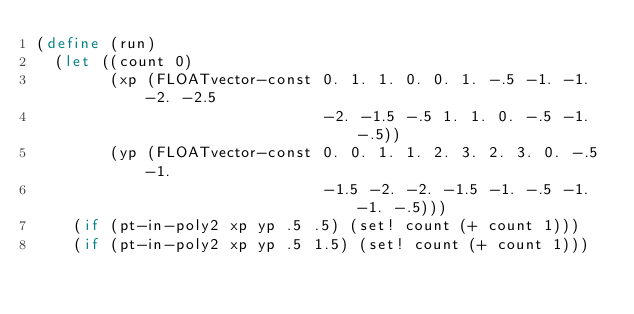<code> <loc_0><loc_0><loc_500><loc_500><_Scheme_>(define (run)
  (let ((count 0)
        (xp (FLOATvector-const 0. 1. 1. 0. 0. 1. -.5 -1. -1. -2. -2.5
                               -2. -1.5 -.5 1. 1. 0. -.5 -1. -.5))
        (yp (FLOATvector-const 0. 0. 1. 1. 2. 3. 2. 3. 0. -.5 -1.
                               -1.5 -2. -2. -1.5 -1. -.5 -1. -1. -.5)))
    (if (pt-in-poly2 xp yp .5 .5) (set! count (+ count 1)))
    (if (pt-in-poly2 xp yp .5 1.5) (set! count (+ count 1)))</code> 